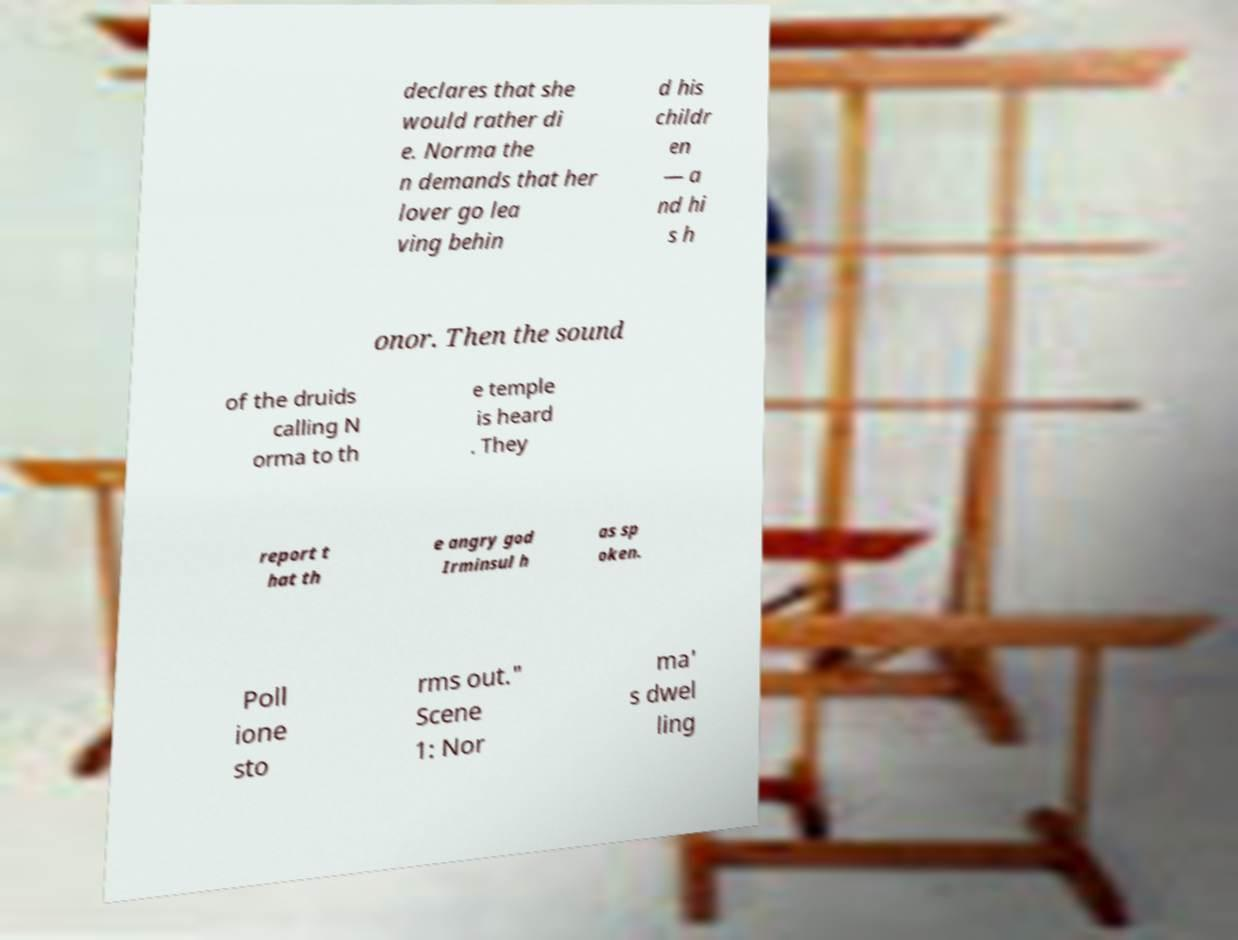Can you accurately transcribe the text from the provided image for me? declares that she would rather di e. Norma the n demands that her lover go lea ving behin d his childr en — a nd hi s h onor. Then the sound of the druids calling N orma to th e temple is heard . They report t hat th e angry god Irminsul h as sp oken. Poll ione sto rms out." Scene 1: Nor ma' s dwel ling 